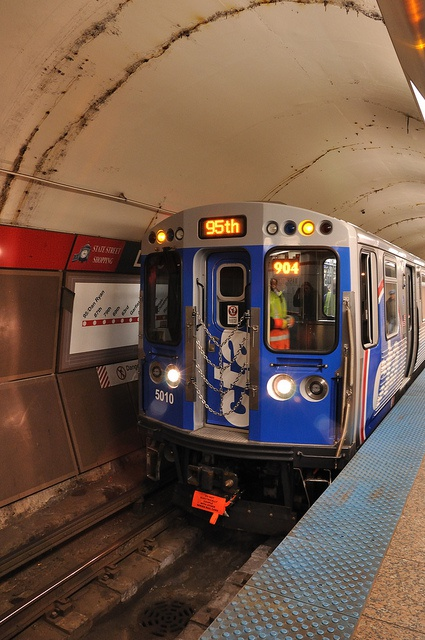Describe the objects in this image and their specific colors. I can see train in gray, black, and navy tones, people in gray, olive, brown, and tan tones, and people in gray, maroon, and black tones in this image. 